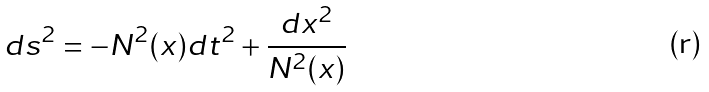<formula> <loc_0><loc_0><loc_500><loc_500>d s ^ { 2 } = - N ^ { 2 } ( x ) d t ^ { 2 } + \frac { d x ^ { 2 } } { N ^ { 2 } ( x ) }</formula> 